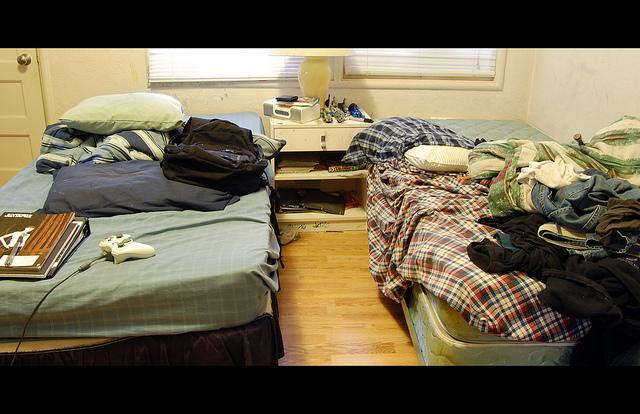Where is the game controller?
Write a very short answer. Bed. What kind of game controller is it?
Keep it brief. Xbox. Are the beds made or unmade?
Be succinct. Unmade. 